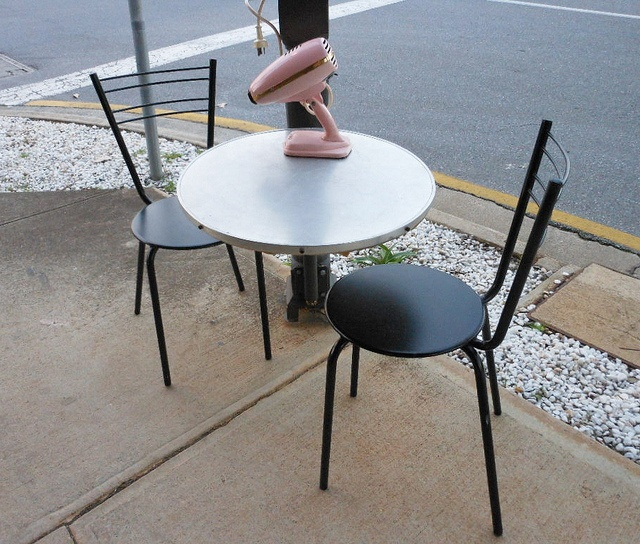Describe the objects in this image and their specific colors. I can see dining table in darkgray and lightgray tones, chair in darkgray, black, and gray tones, chair in darkgray, black, gray, and lightgray tones, and hair drier in darkgray, gray, lightgray, and brown tones in this image. 